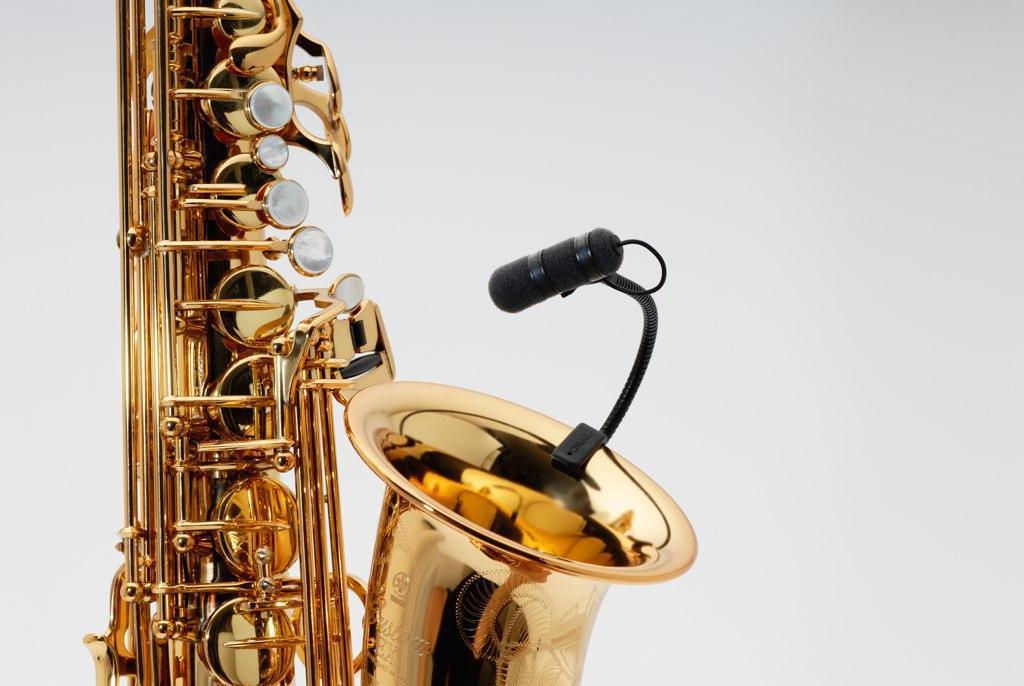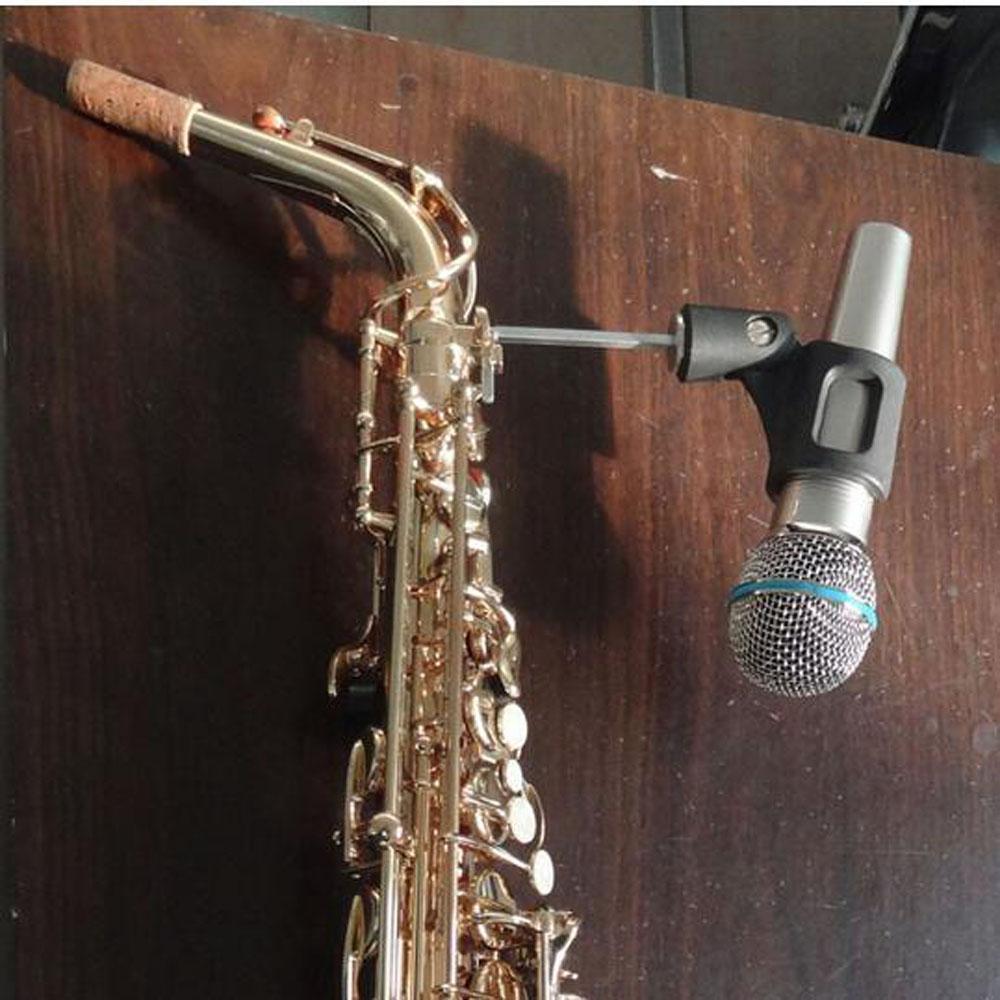The first image is the image on the left, the second image is the image on the right. Given the left and right images, does the statement "At least one image includes a rightward turned man in dark clothing standing and playing a saxophone." hold true? Answer yes or no. No. The first image is the image on the left, the second image is the image on the right. Analyze the images presented: Is the assertion "A man is blowing into the mouthpiece of the saxophone." valid? Answer yes or no. No. 